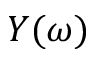Convert formula to latex. <formula><loc_0><loc_0><loc_500><loc_500>Y ( \omega )</formula> 